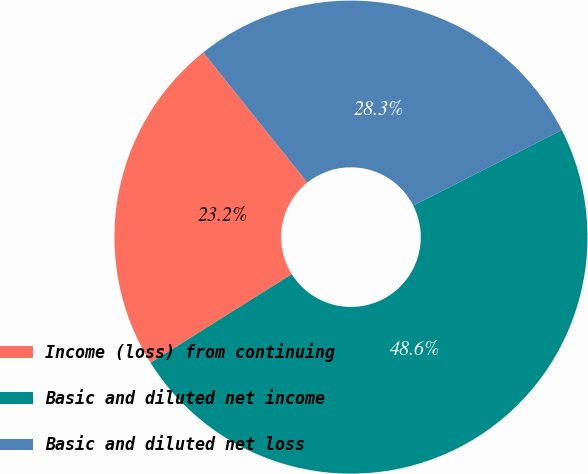<chart> <loc_0><loc_0><loc_500><loc_500><pie_chart><fcel>Income (loss) from continuing<fcel>Basic and diluted net income<fcel>Basic and diluted net loss<nl><fcel>23.18%<fcel>48.56%<fcel>28.26%<nl></chart> 